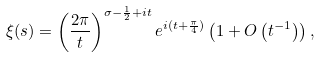Convert formula to latex. <formula><loc_0><loc_0><loc_500><loc_500>\xi ( s ) = \left ( \frac { 2 \pi } { t } \right ) ^ { \sigma - \frac { 1 } { 2 } + i t } e ^ { i ( t + \frac { \pi } 4 ) } \left ( 1 + O \left ( t ^ { - 1 } \right ) \right ) ,</formula> 